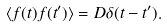<formula> <loc_0><loc_0><loc_500><loc_500>\langle f ( t ) f ( t ^ { \prime } ) \rangle = D \delta ( t - t ^ { \prime } ) .</formula> 